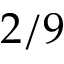Convert formula to latex. <formula><loc_0><loc_0><loc_500><loc_500>2 / 9</formula> 